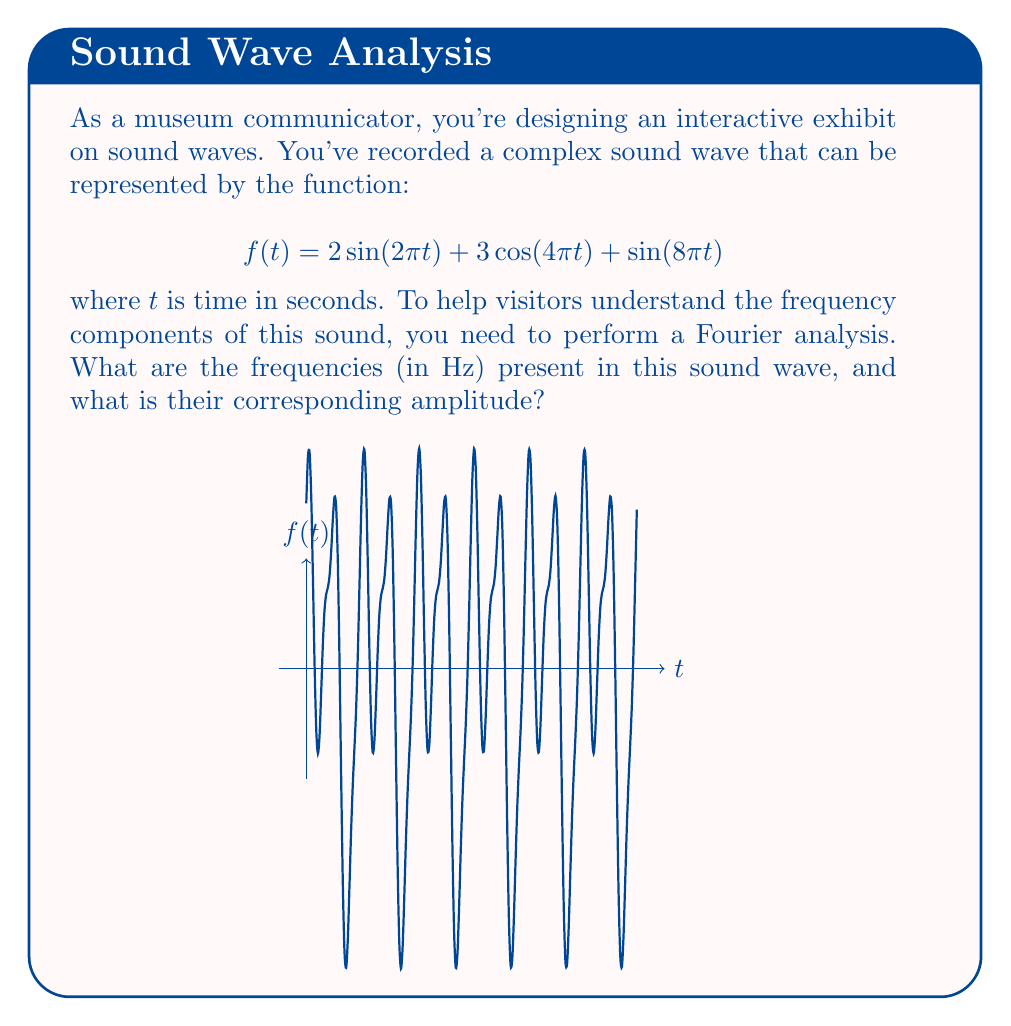Give your solution to this math problem. To analyze the frequency components of the given sound wave, we'll follow these steps:

1) Recall that the general form of a sinusoidal function is:
   $$A\sin(2\pi ft) \text{ or } A\cos(2\pi ft)$$
   where $A$ is the amplitude and $f$ is the frequency in Hz.

2) In our function $f(t) = 2\sin(2\pi t) + 3\cos(4\pi t) + \sin(8\pi t)$, we have three terms:

   a) $2\sin(2\pi t)$
      Comparing with the general form, we see that $A = 2$ and $2\pi f = 2\pi$
      So, $f = 1$ Hz and amplitude is 2

   b) $3\cos(4\pi t)$
      Here, $A = 3$ and $2\pi f = 4\pi$
      So, $f = 2$ Hz and amplitude is 3

   c) $\sin(8\pi t)$
      Here, $A = 1$ and $2\pi f = 8\pi$
      So, $f = 4$ Hz and amplitude is 1

3) Therefore, the sound wave contains three frequency components: 1 Hz, 2 Hz, and 4 Hz, with amplitudes 2, 3, and 1 respectively.
Answer: 1 Hz (amplitude 2), 2 Hz (amplitude 3), 4 Hz (amplitude 1) 